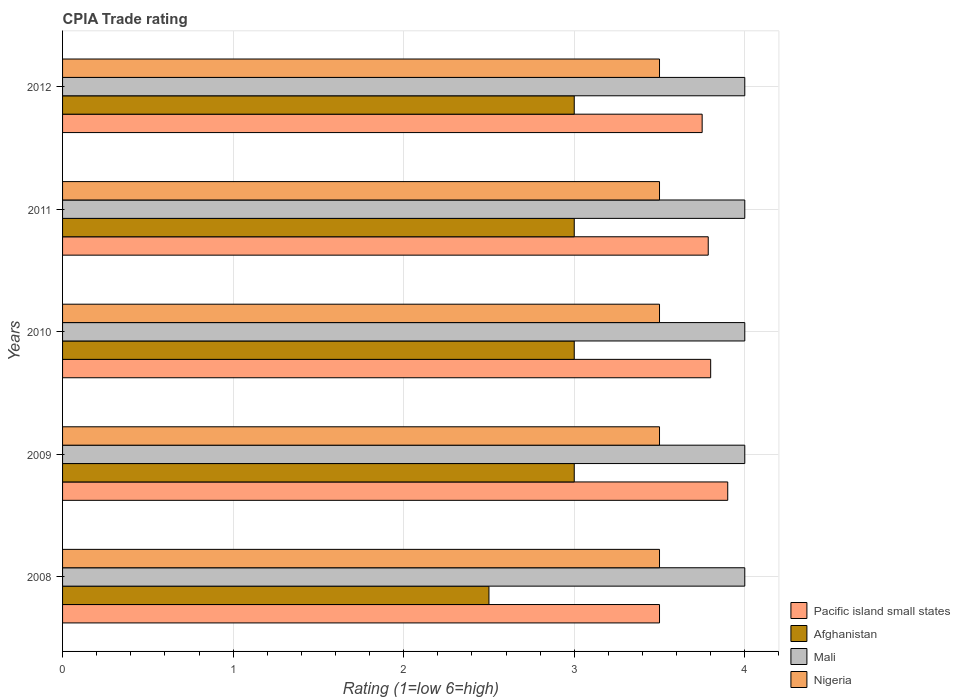How many different coloured bars are there?
Ensure brevity in your answer.  4. How many groups of bars are there?
Keep it short and to the point. 5. Are the number of bars per tick equal to the number of legend labels?
Give a very brief answer. Yes. Are the number of bars on each tick of the Y-axis equal?
Make the answer very short. Yes. What is the label of the 3rd group of bars from the top?
Offer a terse response. 2010. In how many cases, is the number of bars for a given year not equal to the number of legend labels?
Your answer should be very brief. 0. What is the CPIA rating in Mali in 2008?
Provide a succinct answer. 4. Across all years, what is the minimum CPIA rating in Mali?
Offer a terse response. 4. What is the total CPIA rating in Mali in the graph?
Offer a terse response. 20. What is the difference between the CPIA rating in Nigeria in 2009 and that in 2012?
Offer a terse response. 0. What is the difference between the CPIA rating in Pacific island small states in 2009 and the CPIA rating in Mali in 2012?
Give a very brief answer. -0.1. In the year 2011, what is the difference between the CPIA rating in Nigeria and CPIA rating in Mali?
Offer a very short reply. -0.5. What is the ratio of the CPIA rating in Mali in 2008 to that in 2010?
Your answer should be compact. 1. In how many years, is the CPIA rating in Pacific island small states greater than the average CPIA rating in Pacific island small states taken over all years?
Make the answer very short. 4. Is the sum of the CPIA rating in Pacific island small states in 2008 and 2009 greater than the maximum CPIA rating in Afghanistan across all years?
Make the answer very short. Yes. Is it the case that in every year, the sum of the CPIA rating in Afghanistan and CPIA rating in Pacific island small states is greater than the sum of CPIA rating in Nigeria and CPIA rating in Mali?
Provide a succinct answer. No. What does the 3rd bar from the top in 2010 represents?
Your answer should be very brief. Afghanistan. What does the 4th bar from the bottom in 2011 represents?
Your response must be concise. Nigeria. How many bars are there?
Your answer should be compact. 20. Are all the bars in the graph horizontal?
Provide a short and direct response. Yes. What is the difference between two consecutive major ticks on the X-axis?
Give a very brief answer. 1. Are the values on the major ticks of X-axis written in scientific E-notation?
Your response must be concise. No. Does the graph contain any zero values?
Give a very brief answer. No. Where does the legend appear in the graph?
Your answer should be very brief. Bottom right. How are the legend labels stacked?
Offer a terse response. Vertical. What is the title of the graph?
Provide a short and direct response. CPIA Trade rating. Does "Trinidad and Tobago" appear as one of the legend labels in the graph?
Your response must be concise. No. What is the label or title of the X-axis?
Provide a succinct answer. Rating (1=low 6=high). What is the label or title of the Y-axis?
Provide a short and direct response. Years. What is the Rating (1=low 6=high) in Afghanistan in 2008?
Keep it short and to the point. 2.5. What is the Rating (1=low 6=high) of Mali in 2008?
Provide a short and direct response. 4. What is the Rating (1=low 6=high) in Nigeria in 2009?
Provide a short and direct response. 3.5. What is the Rating (1=low 6=high) in Pacific island small states in 2010?
Offer a terse response. 3.8. What is the Rating (1=low 6=high) of Afghanistan in 2010?
Your answer should be compact. 3. What is the Rating (1=low 6=high) in Pacific island small states in 2011?
Keep it short and to the point. 3.79. What is the Rating (1=low 6=high) in Pacific island small states in 2012?
Provide a short and direct response. 3.75. What is the Rating (1=low 6=high) in Afghanistan in 2012?
Ensure brevity in your answer.  3. Across all years, what is the maximum Rating (1=low 6=high) of Pacific island small states?
Offer a terse response. 3.9. Across all years, what is the maximum Rating (1=low 6=high) of Afghanistan?
Keep it short and to the point. 3. Across all years, what is the maximum Rating (1=low 6=high) in Mali?
Offer a terse response. 4. Across all years, what is the maximum Rating (1=low 6=high) in Nigeria?
Offer a very short reply. 3.5. Across all years, what is the minimum Rating (1=low 6=high) of Pacific island small states?
Your answer should be compact. 3.5. Across all years, what is the minimum Rating (1=low 6=high) of Afghanistan?
Offer a terse response. 2.5. Across all years, what is the minimum Rating (1=low 6=high) of Mali?
Give a very brief answer. 4. Across all years, what is the minimum Rating (1=low 6=high) of Nigeria?
Your answer should be compact. 3.5. What is the total Rating (1=low 6=high) in Pacific island small states in the graph?
Offer a very short reply. 18.74. What is the total Rating (1=low 6=high) of Afghanistan in the graph?
Keep it short and to the point. 14.5. What is the total Rating (1=low 6=high) in Nigeria in the graph?
Your answer should be compact. 17.5. What is the difference between the Rating (1=low 6=high) in Mali in 2008 and that in 2009?
Your answer should be compact. 0. What is the difference between the Rating (1=low 6=high) of Nigeria in 2008 and that in 2009?
Make the answer very short. 0. What is the difference between the Rating (1=low 6=high) in Mali in 2008 and that in 2010?
Your answer should be very brief. 0. What is the difference between the Rating (1=low 6=high) of Pacific island small states in 2008 and that in 2011?
Your answer should be compact. -0.29. What is the difference between the Rating (1=low 6=high) of Afghanistan in 2008 and that in 2011?
Your answer should be very brief. -0.5. What is the difference between the Rating (1=low 6=high) in Pacific island small states in 2008 and that in 2012?
Provide a short and direct response. -0.25. What is the difference between the Rating (1=low 6=high) in Pacific island small states in 2009 and that in 2010?
Provide a succinct answer. 0.1. What is the difference between the Rating (1=low 6=high) of Nigeria in 2009 and that in 2010?
Offer a very short reply. 0. What is the difference between the Rating (1=low 6=high) in Pacific island small states in 2009 and that in 2011?
Give a very brief answer. 0.11. What is the difference between the Rating (1=low 6=high) of Afghanistan in 2009 and that in 2011?
Make the answer very short. 0. What is the difference between the Rating (1=low 6=high) of Afghanistan in 2009 and that in 2012?
Give a very brief answer. 0. What is the difference between the Rating (1=low 6=high) in Nigeria in 2009 and that in 2012?
Ensure brevity in your answer.  0. What is the difference between the Rating (1=low 6=high) in Pacific island small states in 2010 and that in 2011?
Offer a very short reply. 0.01. What is the difference between the Rating (1=low 6=high) of Afghanistan in 2010 and that in 2011?
Offer a very short reply. 0. What is the difference between the Rating (1=low 6=high) of Pacific island small states in 2010 and that in 2012?
Offer a terse response. 0.05. What is the difference between the Rating (1=low 6=high) of Mali in 2010 and that in 2012?
Ensure brevity in your answer.  0. What is the difference between the Rating (1=low 6=high) in Nigeria in 2010 and that in 2012?
Offer a very short reply. 0. What is the difference between the Rating (1=low 6=high) of Pacific island small states in 2011 and that in 2012?
Provide a short and direct response. 0.04. What is the difference between the Rating (1=low 6=high) of Afghanistan in 2011 and that in 2012?
Your answer should be compact. 0. What is the difference between the Rating (1=low 6=high) of Afghanistan in 2008 and the Rating (1=low 6=high) of Mali in 2009?
Your response must be concise. -1.5. What is the difference between the Rating (1=low 6=high) in Mali in 2008 and the Rating (1=low 6=high) in Nigeria in 2009?
Make the answer very short. 0.5. What is the difference between the Rating (1=low 6=high) of Mali in 2008 and the Rating (1=low 6=high) of Nigeria in 2010?
Ensure brevity in your answer.  0.5. What is the difference between the Rating (1=low 6=high) in Pacific island small states in 2008 and the Rating (1=low 6=high) in Mali in 2011?
Provide a short and direct response. -0.5. What is the difference between the Rating (1=low 6=high) in Afghanistan in 2008 and the Rating (1=low 6=high) in Nigeria in 2011?
Ensure brevity in your answer.  -1. What is the difference between the Rating (1=low 6=high) of Mali in 2008 and the Rating (1=low 6=high) of Nigeria in 2011?
Provide a short and direct response. 0.5. What is the difference between the Rating (1=low 6=high) of Pacific island small states in 2008 and the Rating (1=low 6=high) of Mali in 2012?
Provide a succinct answer. -0.5. What is the difference between the Rating (1=low 6=high) of Afghanistan in 2008 and the Rating (1=low 6=high) of Mali in 2012?
Provide a short and direct response. -1.5. What is the difference between the Rating (1=low 6=high) of Pacific island small states in 2009 and the Rating (1=low 6=high) of Afghanistan in 2010?
Your response must be concise. 0.9. What is the difference between the Rating (1=low 6=high) of Pacific island small states in 2009 and the Rating (1=low 6=high) of Nigeria in 2010?
Offer a very short reply. 0.4. What is the difference between the Rating (1=low 6=high) in Mali in 2009 and the Rating (1=low 6=high) in Nigeria in 2010?
Provide a succinct answer. 0.5. What is the difference between the Rating (1=low 6=high) of Pacific island small states in 2009 and the Rating (1=low 6=high) of Afghanistan in 2011?
Your answer should be compact. 0.9. What is the difference between the Rating (1=low 6=high) in Pacific island small states in 2009 and the Rating (1=low 6=high) in Mali in 2011?
Provide a succinct answer. -0.1. What is the difference between the Rating (1=low 6=high) in Afghanistan in 2009 and the Rating (1=low 6=high) in Mali in 2011?
Keep it short and to the point. -1. What is the difference between the Rating (1=low 6=high) in Pacific island small states in 2009 and the Rating (1=low 6=high) in Mali in 2012?
Provide a succinct answer. -0.1. What is the difference between the Rating (1=low 6=high) in Afghanistan in 2009 and the Rating (1=low 6=high) in Mali in 2012?
Make the answer very short. -1. What is the difference between the Rating (1=low 6=high) in Pacific island small states in 2010 and the Rating (1=low 6=high) in Afghanistan in 2011?
Make the answer very short. 0.8. What is the difference between the Rating (1=low 6=high) in Pacific island small states in 2010 and the Rating (1=low 6=high) in Nigeria in 2011?
Your answer should be compact. 0.3. What is the difference between the Rating (1=low 6=high) in Afghanistan in 2010 and the Rating (1=low 6=high) in Mali in 2011?
Ensure brevity in your answer.  -1. What is the difference between the Rating (1=low 6=high) of Mali in 2010 and the Rating (1=low 6=high) of Nigeria in 2011?
Your answer should be very brief. 0.5. What is the difference between the Rating (1=low 6=high) in Pacific island small states in 2010 and the Rating (1=low 6=high) in Mali in 2012?
Offer a terse response. -0.2. What is the difference between the Rating (1=low 6=high) in Afghanistan in 2010 and the Rating (1=low 6=high) in Nigeria in 2012?
Your response must be concise. -0.5. What is the difference between the Rating (1=low 6=high) in Mali in 2010 and the Rating (1=low 6=high) in Nigeria in 2012?
Offer a very short reply. 0.5. What is the difference between the Rating (1=low 6=high) in Pacific island small states in 2011 and the Rating (1=low 6=high) in Afghanistan in 2012?
Keep it short and to the point. 0.79. What is the difference between the Rating (1=low 6=high) of Pacific island small states in 2011 and the Rating (1=low 6=high) of Mali in 2012?
Offer a terse response. -0.21. What is the difference between the Rating (1=low 6=high) of Pacific island small states in 2011 and the Rating (1=low 6=high) of Nigeria in 2012?
Make the answer very short. 0.29. What is the difference between the Rating (1=low 6=high) of Afghanistan in 2011 and the Rating (1=low 6=high) of Mali in 2012?
Offer a terse response. -1. What is the difference between the Rating (1=low 6=high) of Afghanistan in 2011 and the Rating (1=low 6=high) of Nigeria in 2012?
Provide a succinct answer. -0.5. What is the difference between the Rating (1=low 6=high) in Mali in 2011 and the Rating (1=low 6=high) in Nigeria in 2012?
Your answer should be very brief. 0.5. What is the average Rating (1=low 6=high) of Pacific island small states per year?
Offer a terse response. 3.75. In the year 2008, what is the difference between the Rating (1=low 6=high) of Pacific island small states and Rating (1=low 6=high) of Afghanistan?
Make the answer very short. 1. In the year 2008, what is the difference between the Rating (1=low 6=high) of Afghanistan and Rating (1=low 6=high) of Mali?
Provide a short and direct response. -1.5. In the year 2008, what is the difference between the Rating (1=low 6=high) of Mali and Rating (1=low 6=high) of Nigeria?
Offer a very short reply. 0.5. In the year 2009, what is the difference between the Rating (1=low 6=high) of Pacific island small states and Rating (1=low 6=high) of Mali?
Give a very brief answer. -0.1. In the year 2009, what is the difference between the Rating (1=low 6=high) of Afghanistan and Rating (1=low 6=high) of Nigeria?
Your response must be concise. -0.5. In the year 2010, what is the difference between the Rating (1=low 6=high) of Pacific island small states and Rating (1=low 6=high) of Afghanistan?
Your answer should be compact. 0.8. In the year 2011, what is the difference between the Rating (1=low 6=high) of Pacific island small states and Rating (1=low 6=high) of Afghanistan?
Keep it short and to the point. 0.79. In the year 2011, what is the difference between the Rating (1=low 6=high) of Pacific island small states and Rating (1=low 6=high) of Mali?
Offer a very short reply. -0.21. In the year 2011, what is the difference between the Rating (1=low 6=high) in Pacific island small states and Rating (1=low 6=high) in Nigeria?
Your answer should be compact. 0.29. In the year 2011, what is the difference between the Rating (1=low 6=high) of Mali and Rating (1=low 6=high) of Nigeria?
Make the answer very short. 0.5. In the year 2012, what is the difference between the Rating (1=low 6=high) in Pacific island small states and Rating (1=low 6=high) in Mali?
Provide a succinct answer. -0.25. In the year 2012, what is the difference between the Rating (1=low 6=high) of Afghanistan and Rating (1=low 6=high) of Mali?
Offer a very short reply. -1. In the year 2012, what is the difference between the Rating (1=low 6=high) of Afghanistan and Rating (1=low 6=high) of Nigeria?
Keep it short and to the point. -0.5. In the year 2012, what is the difference between the Rating (1=low 6=high) of Mali and Rating (1=low 6=high) of Nigeria?
Give a very brief answer. 0.5. What is the ratio of the Rating (1=low 6=high) in Pacific island small states in 2008 to that in 2009?
Provide a short and direct response. 0.9. What is the ratio of the Rating (1=low 6=high) of Nigeria in 2008 to that in 2009?
Your answer should be compact. 1. What is the ratio of the Rating (1=low 6=high) of Pacific island small states in 2008 to that in 2010?
Offer a terse response. 0.92. What is the ratio of the Rating (1=low 6=high) in Afghanistan in 2008 to that in 2010?
Ensure brevity in your answer.  0.83. What is the ratio of the Rating (1=low 6=high) in Nigeria in 2008 to that in 2010?
Offer a terse response. 1. What is the ratio of the Rating (1=low 6=high) in Pacific island small states in 2008 to that in 2011?
Your answer should be compact. 0.92. What is the ratio of the Rating (1=low 6=high) of Mali in 2008 to that in 2011?
Provide a succinct answer. 1. What is the ratio of the Rating (1=low 6=high) of Pacific island small states in 2008 to that in 2012?
Your response must be concise. 0.93. What is the ratio of the Rating (1=low 6=high) of Nigeria in 2008 to that in 2012?
Your answer should be compact. 1. What is the ratio of the Rating (1=low 6=high) in Pacific island small states in 2009 to that in 2010?
Keep it short and to the point. 1.03. What is the ratio of the Rating (1=low 6=high) in Afghanistan in 2009 to that in 2010?
Ensure brevity in your answer.  1. What is the ratio of the Rating (1=low 6=high) in Mali in 2009 to that in 2010?
Offer a terse response. 1. What is the ratio of the Rating (1=low 6=high) in Nigeria in 2009 to that in 2010?
Give a very brief answer. 1. What is the ratio of the Rating (1=low 6=high) of Pacific island small states in 2009 to that in 2011?
Keep it short and to the point. 1.03. What is the ratio of the Rating (1=low 6=high) in Pacific island small states in 2009 to that in 2012?
Make the answer very short. 1.04. What is the ratio of the Rating (1=low 6=high) in Mali in 2009 to that in 2012?
Your answer should be compact. 1. What is the ratio of the Rating (1=low 6=high) in Pacific island small states in 2010 to that in 2011?
Ensure brevity in your answer.  1. What is the ratio of the Rating (1=low 6=high) of Nigeria in 2010 to that in 2011?
Provide a short and direct response. 1. What is the ratio of the Rating (1=low 6=high) of Pacific island small states in 2010 to that in 2012?
Your response must be concise. 1.01. What is the ratio of the Rating (1=low 6=high) in Pacific island small states in 2011 to that in 2012?
Ensure brevity in your answer.  1.01. What is the ratio of the Rating (1=low 6=high) in Mali in 2011 to that in 2012?
Ensure brevity in your answer.  1. What is the difference between the highest and the second highest Rating (1=low 6=high) in Afghanistan?
Provide a succinct answer. 0. What is the difference between the highest and the second highest Rating (1=low 6=high) in Mali?
Keep it short and to the point. 0. What is the difference between the highest and the second highest Rating (1=low 6=high) in Nigeria?
Provide a succinct answer. 0. What is the difference between the highest and the lowest Rating (1=low 6=high) in Afghanistan?
Your answer should be very brief. 0.5. 